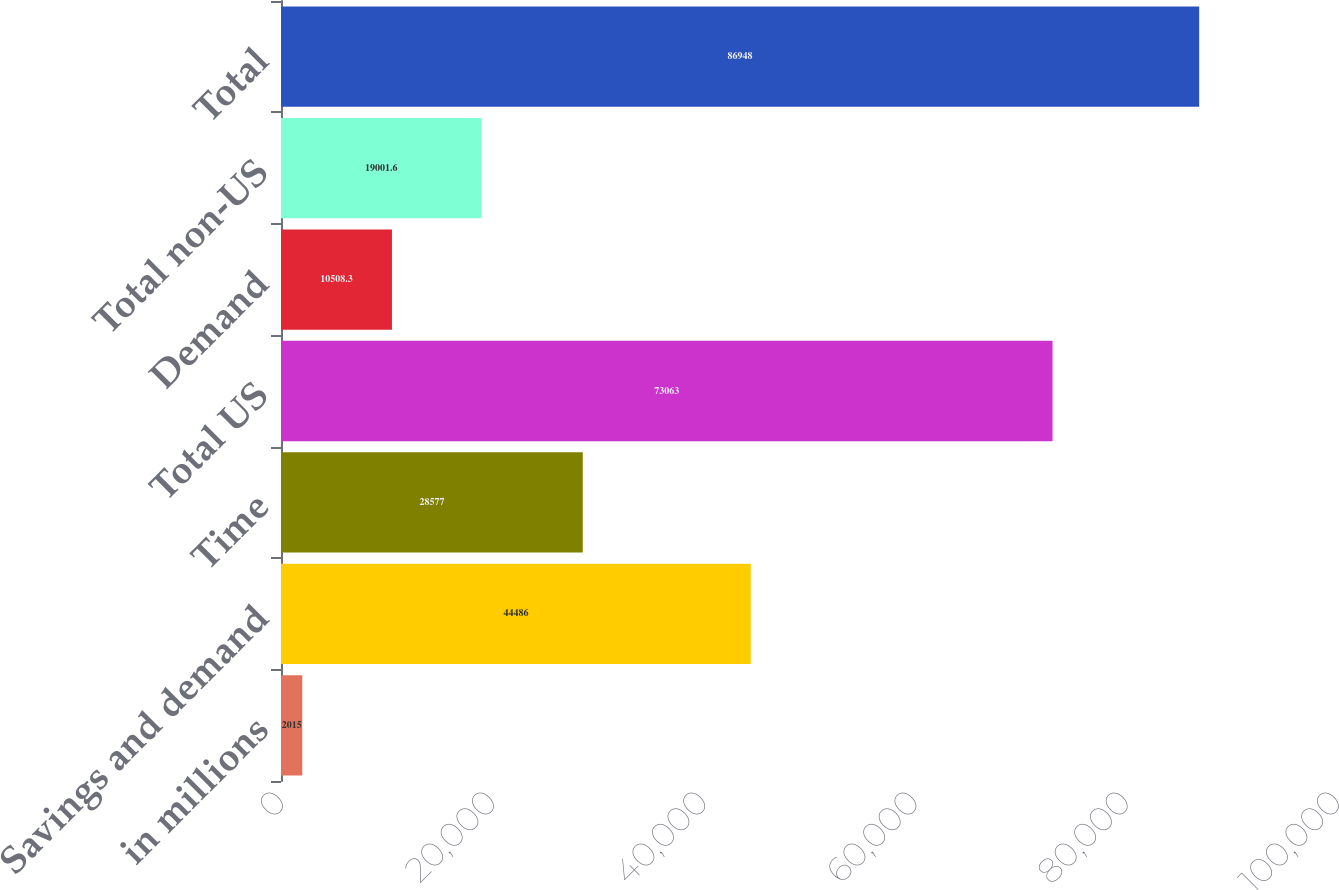Convert chart to OTSL. <chart><loc_0><loc_0><loc_500><loc_500><bar_chart><fcel>in millions<fcel>Savings and demand<fcel>Time<fcel>Total US<fcel>Demand<fcel>Total non-US<fcel>Total<nl><fcel>2015<fcel>44486<fcel>28577<fcel>73063<fcel>10508.3<fcel>19001.6<fcel>86948<nl></chart> 